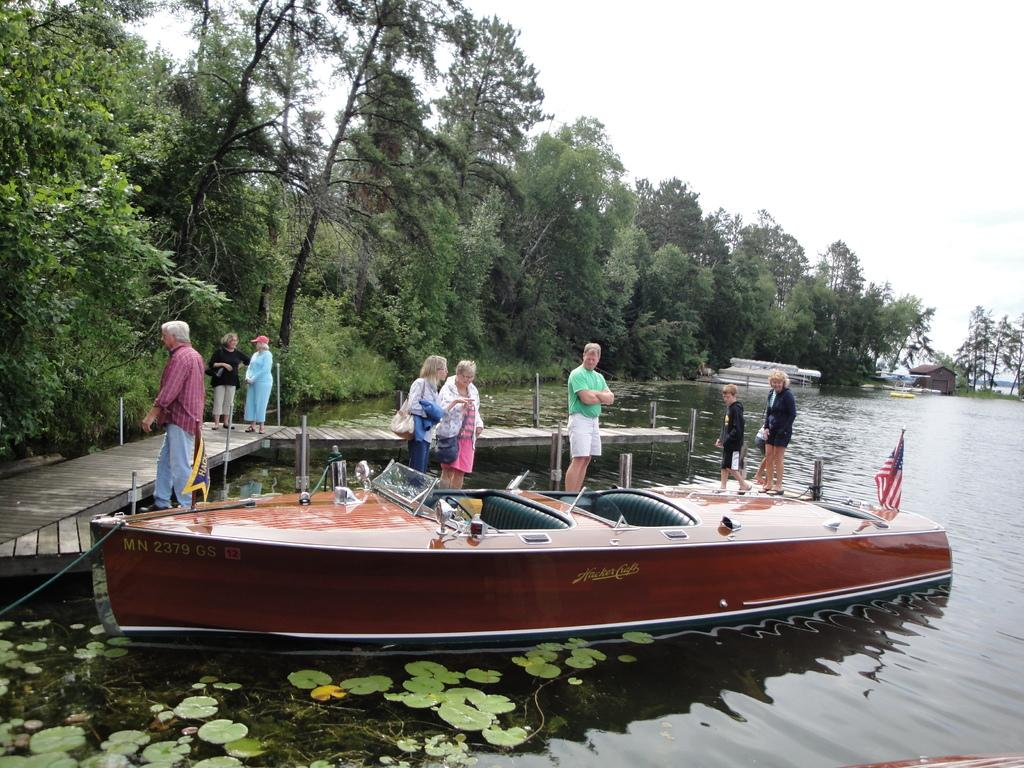What is the main subject of the image? The main subject of the image is a boat. Are there any structures or objects in the image besides the boat? Yes, there is a small bridge, trees, water, a shelter, and the sky visible in the image. Can you describe the people in the image? There are persons standing on the floor in the image. What is the condition of the sky in the image? The sky is visible in the image. What type of wool is being used to make the tray in the image? There is no wool or tray present in the image. Does the existence of the boat in the image prove the existence of a parallel universe? The presence of a boat in the image does not prove the existence of a parallel universe; it is simply a subject in the image. 